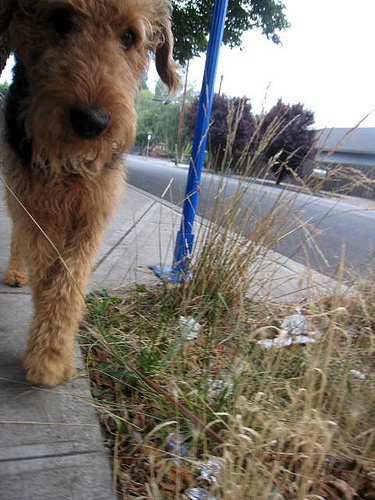Describe the objects in this image and their specific colors. I can see a dog in black, maroon, and gray tones in this image. 